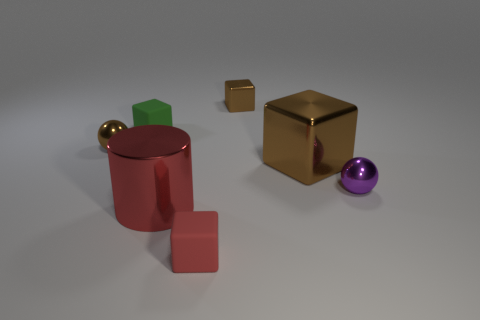Subtract all large brown metallic blocks. How many blocks are left? 3 Add 1 tiny purple metal objects. How many objects exist? 8 Subtract all brown blocks. How many blocks are left? 2 Subtract 1 cylinders. How many cylinders are left? 0 Subtract all yellow spheres. How many brown blocks are left? 2 Subtract all big red things. Subtract all large brown balls. How many objects are left? 6 Add 4 large red things. How many large red things are left? 5 Add 6 red balls. How many red balls exist? 6 Subtract 0 cyan cubes. How many objects are left? 7 Subtract all cubes. How many objects are left? 3 